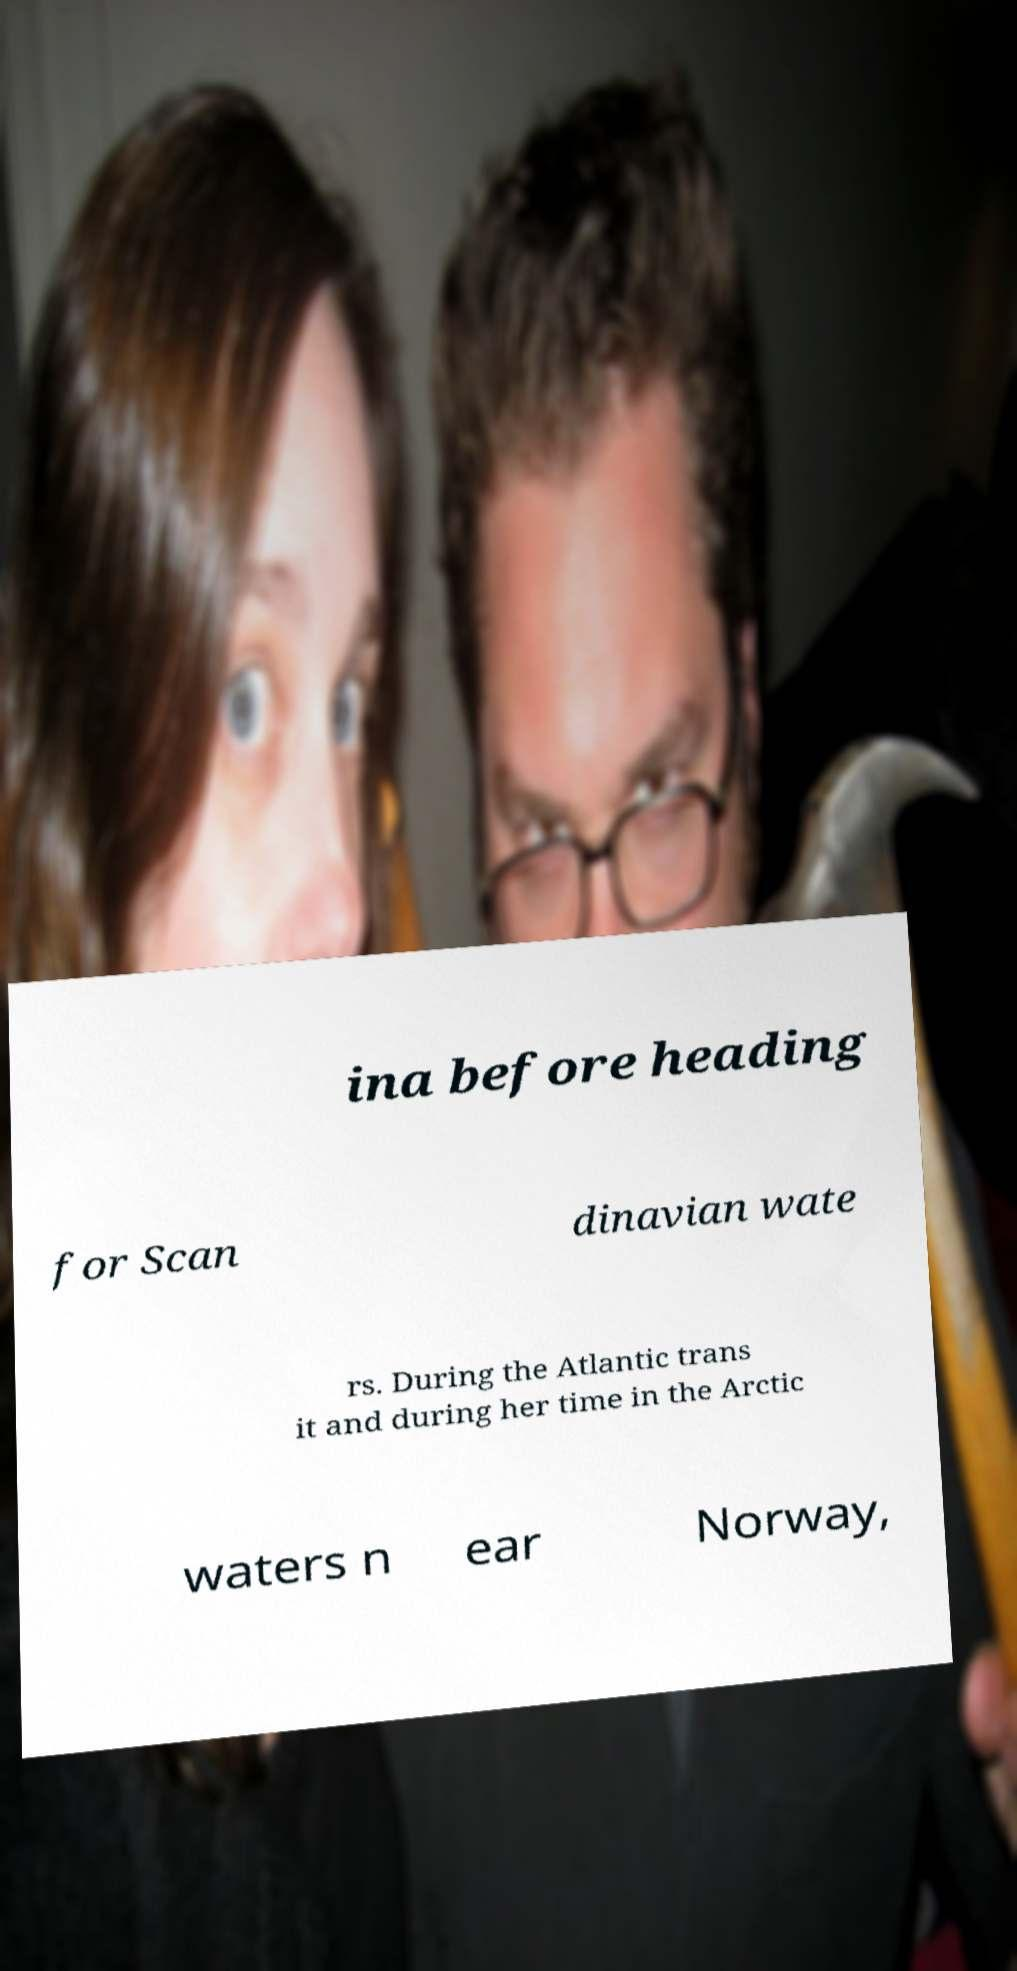Could you assist in decoding the text presented in this image and type it out clearly? ina before heading for Scan dinavian wate rs. During the Atlantic trans it and during her time in the Arctic waters n ear Norway, 